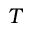<formula> <loc_0><loc_0><loc_500><loc_500>T</formula> 